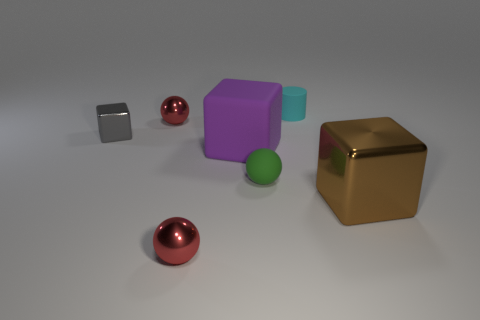There is a shiny cube that is the same size as the cyan object; what color is it?
Give a very brief answer. Gray. Are the large block on the left side of the tiny cylinder and the small block made of the same material?
Give a very brief answer. No. There is a shiny block that is on the left side of the block that is to the right of the small cyan cylinder; is there a sphere in front of it?
Provide a succinct answer. Yes. Do the large object that is left of the cyan matte thing and the big brown thing have the same shape?
Offer a very short reply. Yes. What is the shape of the big rubber object on the right side of the red object that is behind the large brown object?
Offer a very short reply. Cube. How big is the red metallic object on the right side of the red thing that is behind the red ball in front of the gray thing?
Offer a terse response. Small. What color is the other large rubber thing that is the same shape as the gray thing?
Offer a terse response. Purple. Is the green matte sphere the same size as the rubber cylinder?
Offer a terse response. Yes. What is the big object that is to the left of the tiny rubber sphere made of?
Your answer should be very brief. Rubber. How many other objects are the same shape as the cyan object?
Your response must be concise. 0. 